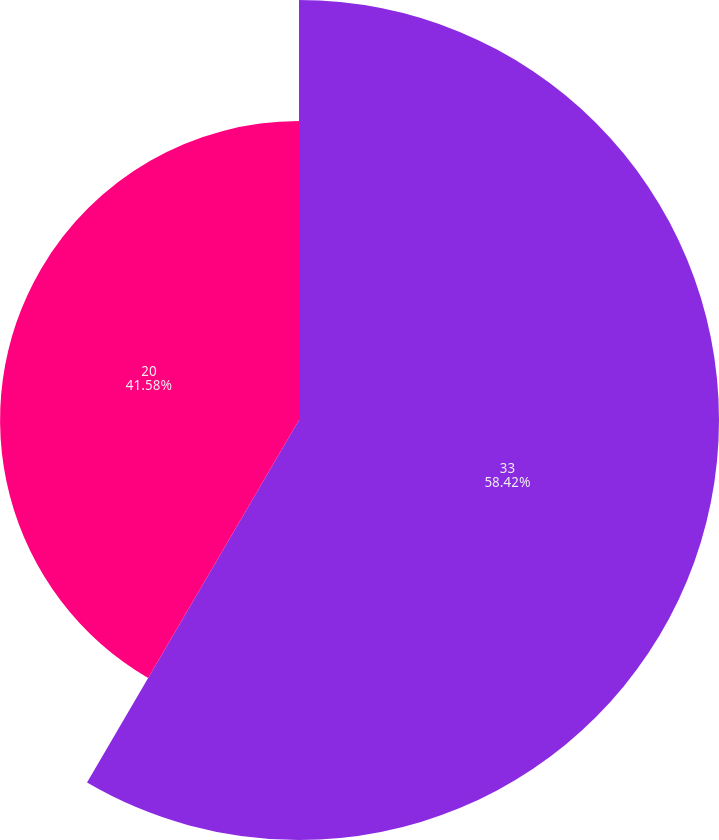<chart> <loc_0><loc_0><loc_500><loc_500><pie_chart><fcel>33<fcel>20<nl><fcel>58.42%<fcel>41.58%<nl></chart> 